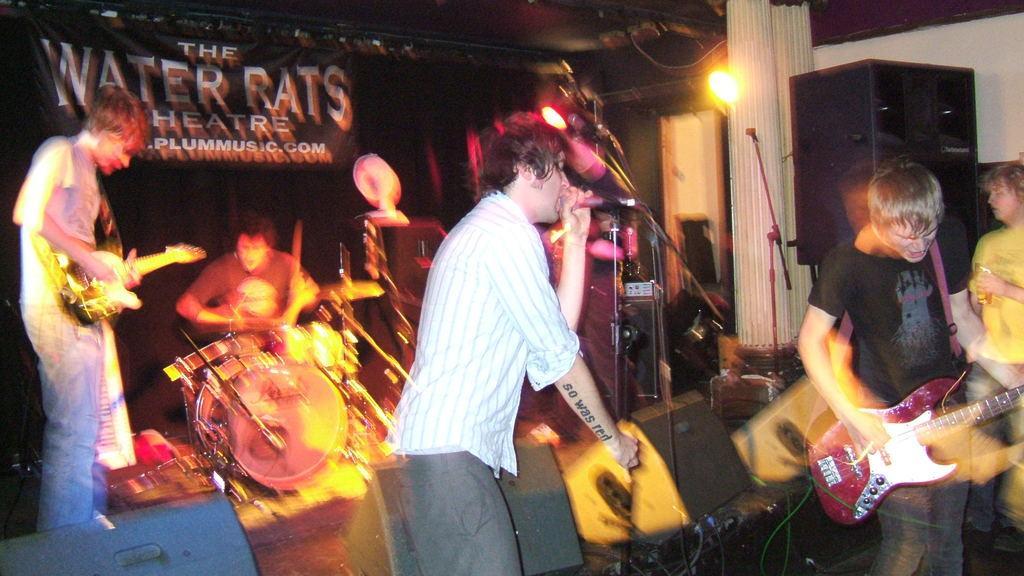How would you summarize this image in a sentence or two? In this picture there are group of people who are playing musical instruments. There is a light and a loudspeaker. 